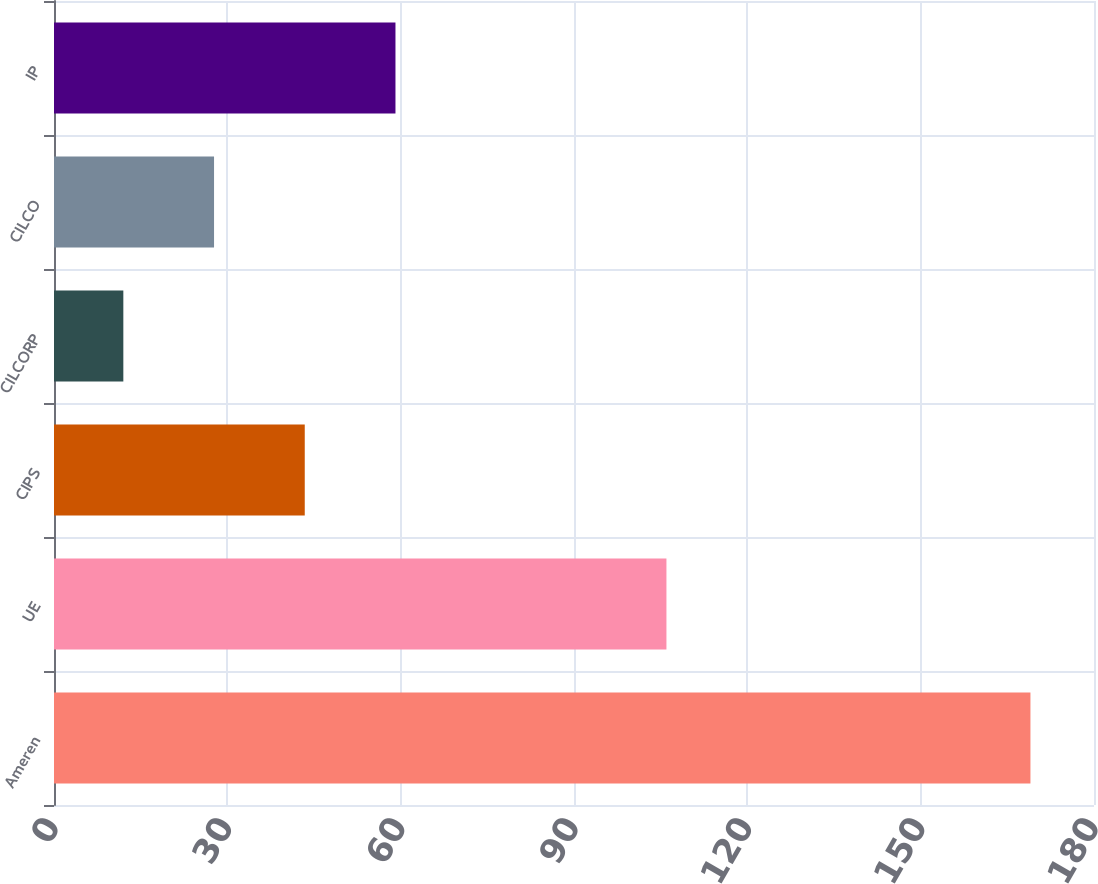<chart> <loc_0><loc_0><loc_500><loc_500><bar_chart><fcel>Ameren<fcel>UE<fcel>CIPS<fcel>CILCORP<fcel>CILCO<fcel>IP<nl><fcel>169<fcel>106<fcel>43.4<fcel>12<fcel>27.7<fcel>59.1<nl></chart> 